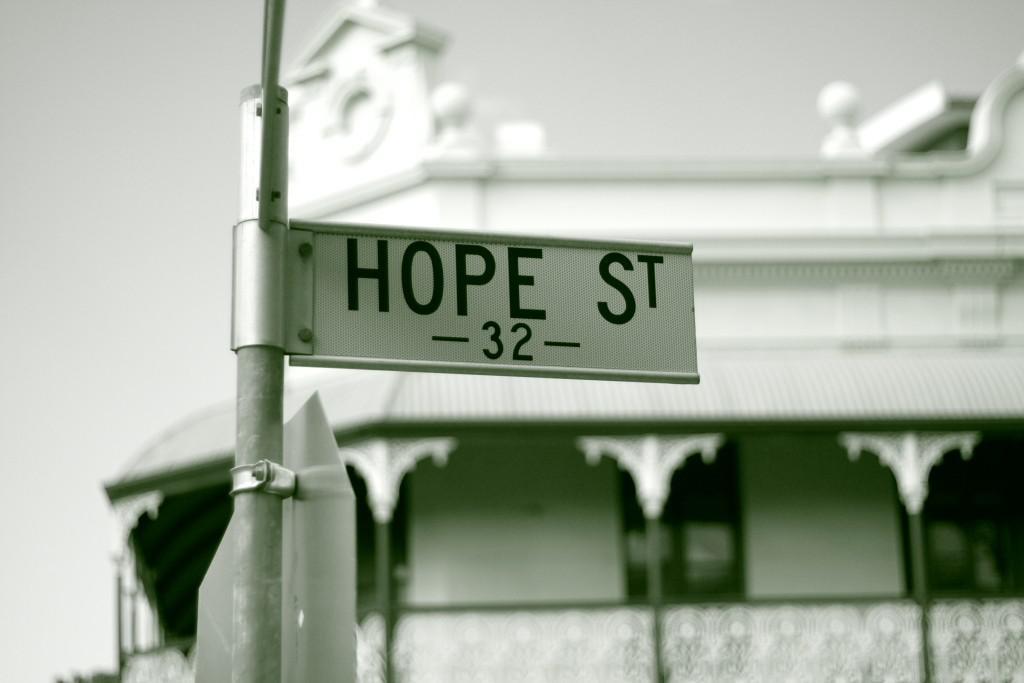Describe this image in one or two sentences. In this image we can see a pole with a sign board. In the back there is a building with pillars. Also there is sky. And it is blurry in the background. 